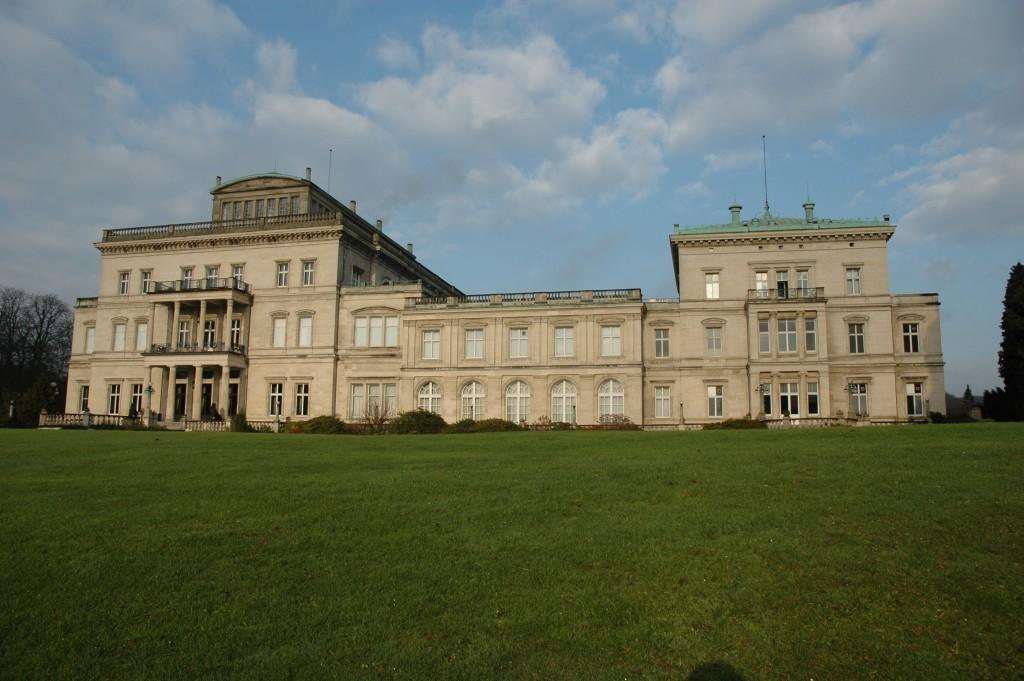Describe this image in one or two sentences. In the front of the image there is grass. Land is covered with grass. In the background of the image there is a building, trees, plants, railing, cloudy sky and objects.   